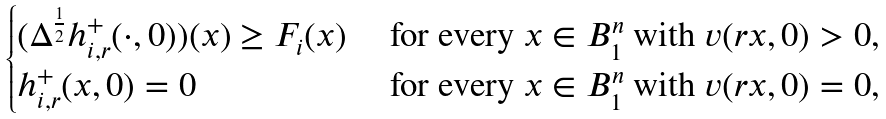Convert formula to latex. <formula><loc_0><loc_0><loc_500><loc_500>\begin{cases} ( \Delta ^ { \frac { 1 } { 2 } } h ^ { + } _ { i , r } ( \cdot , 0 ) ) ( x ) \geq F _ { i } ( x ) & \text { for every } x \in B ^ { n } _ { 1 } \text { with } v ( r x , 0 ) > 0 , \\ h ^ { + } _ { i , r } ( x , 0 ) = 0 & \text { for every } x \in B ^ { n } _ { 1 } \text { with } v ( r x , 0 ) = 0 , \end{cases}</formula> 